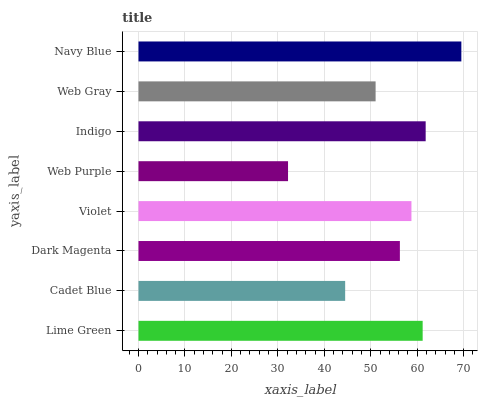Is Web Purple the minimum?
Answer yes or no. Yes. Is Navy Blue the maximum?
Answer yes or no. Yes. Is Cadet Blue the minimum?
Answer yes or no. No. Is Cadet Blue the maximum?
Answer yes or no. No. Is Lime Green greater than Cadet Blue?
Answer yes or no. Yes. Is Cadet Blue less than Lime Green?
Answer yes or no. Yes. Is Cadet Blue greater than Lime Green?
Answer yes or no. No. Is Lime Green less than Cadet Blue?
Answer yes or no. No. Is Violet the high median?
Answer yes or no. Yes. Is Dark Magenta the low median?
Answer yes or no. Yes. Is Web Purple the high median?
Answer yes or no. No. Is Lime Green the low median?
Answer yes or no. No. 